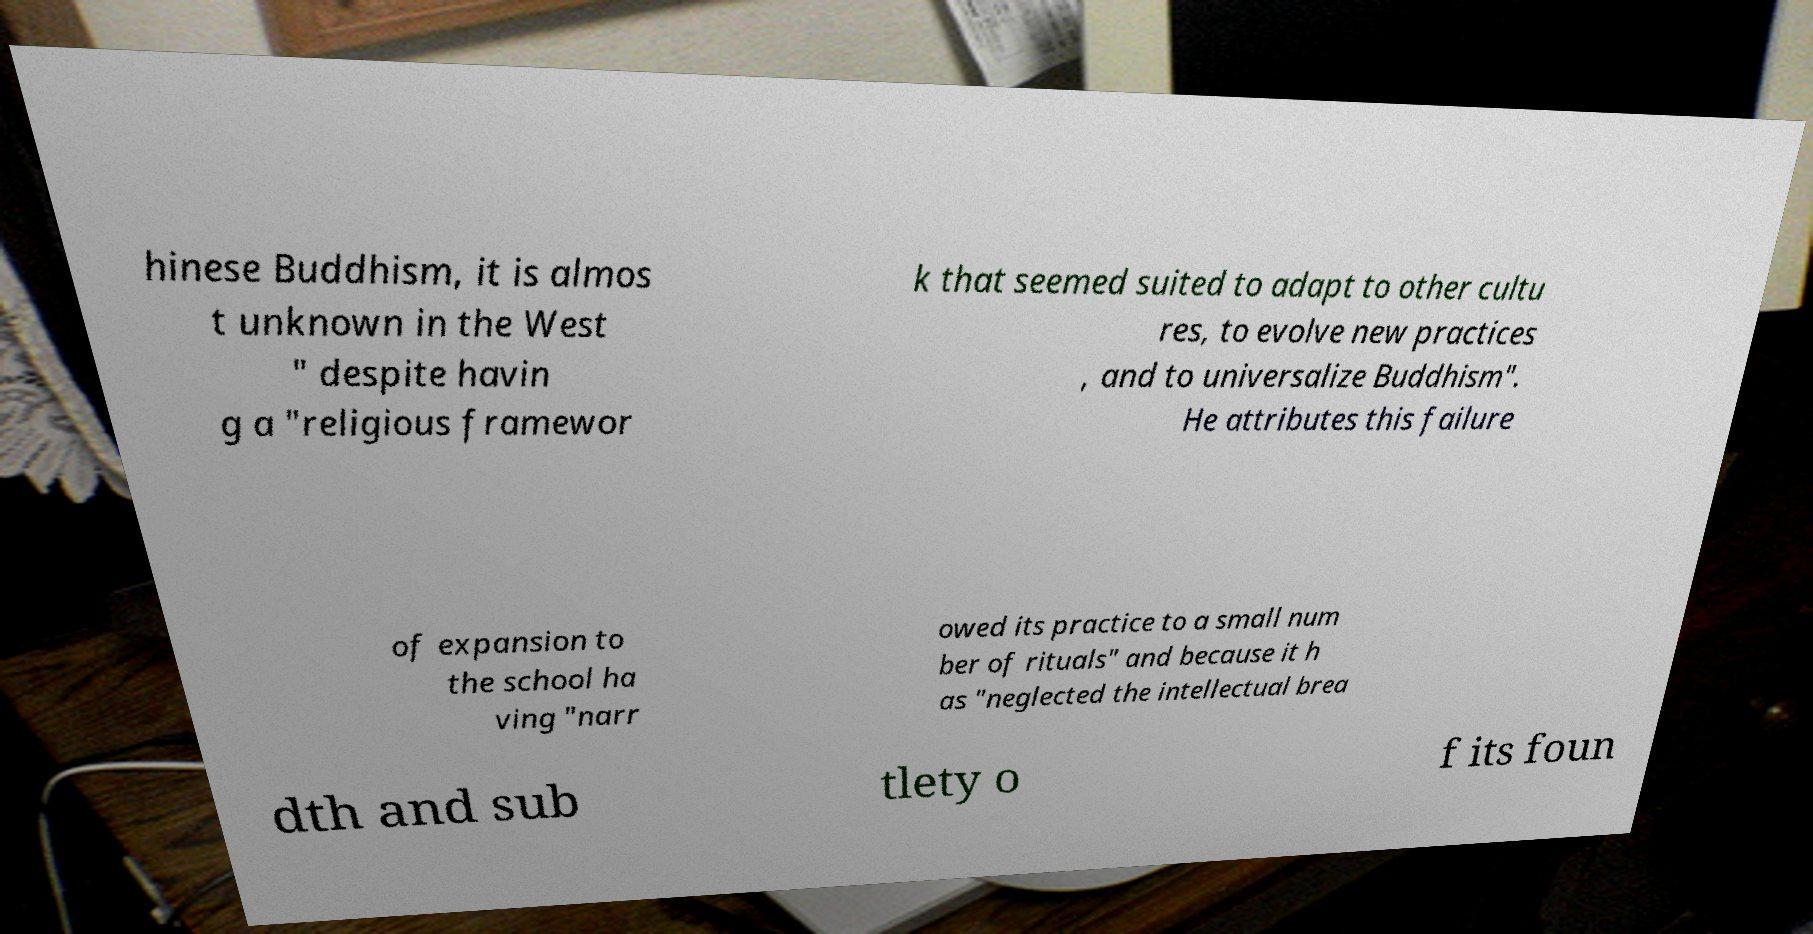I need the written content from this picture converted into text. Can you do that? hinese Buddhism, it is almos t unknown in the West " despite havin g a "religious framewor k that seemed suited to adapt to other cultu res, to evolve new practices , and to universalize Buddhism". He attributes this failure of expansion to the school ha ving "narr owed its practice to a small num ber of rituals" and because it h as "neglected the intellectual brea dth and sub tlety o f its foun 